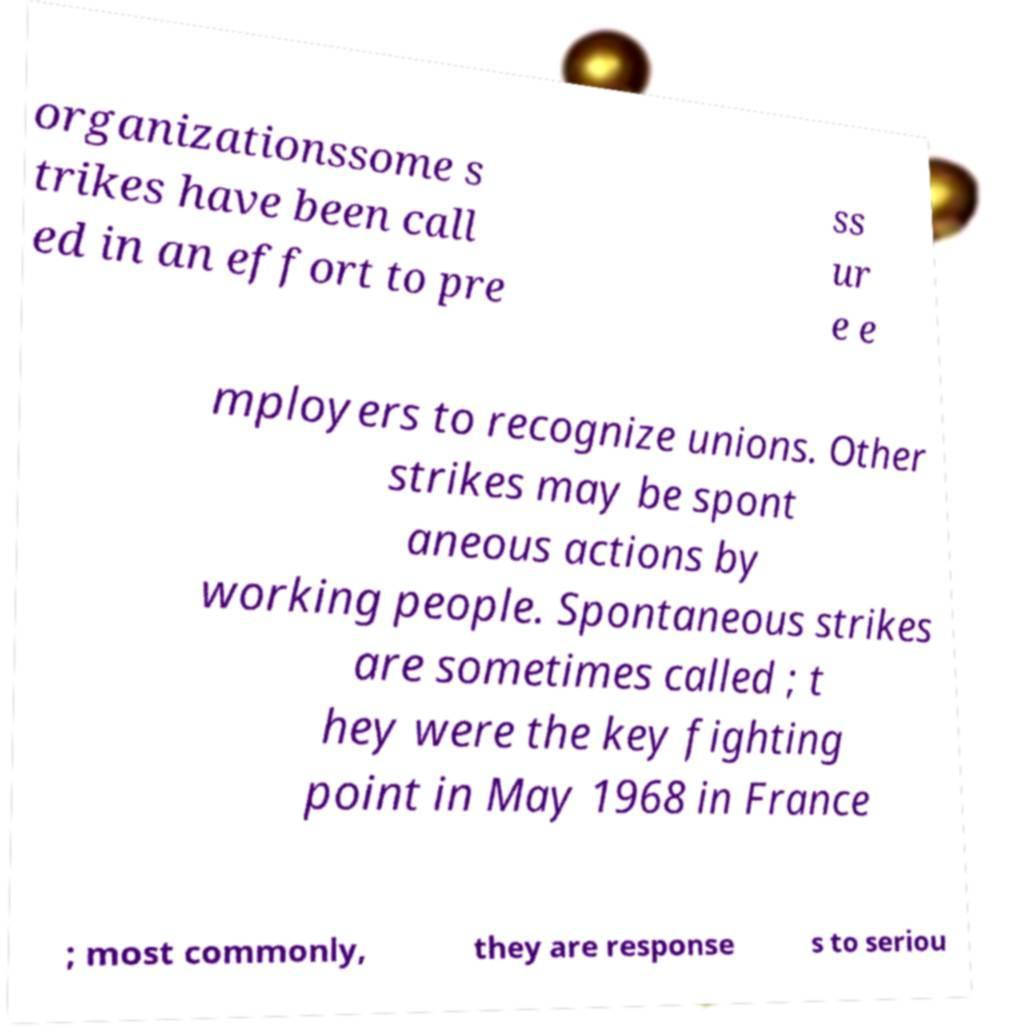Please read and relay the text visible in this image. What does it say? organizationssome s trikes have been call ed in an effort to pre ss ur e e mployers to recognize unions. Other strikes may be spont aneous actions by working people. Spontaneous strikes are sometimes called ; t hey were the key fighting point in May 1968 in France ; most commonly, they are response s to seriou 